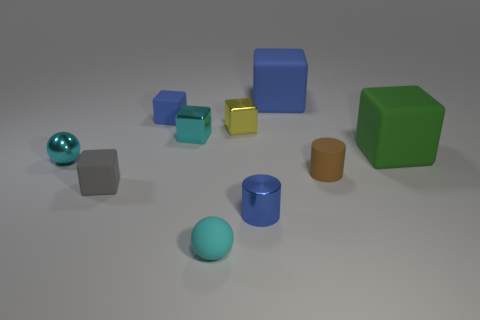Is the number of blue shiny cylinders that are to the left of the tiny gray block less than the number of large cyan matte things?
Your response must be concise. No. What shape is the blue thing that is made of the same material as the yellow cube?
Provide a succinct answer. Cylinder. There is a tiny blue thing that is left of the tiny cyan matte sphere; does it have the same shape as the small blue thing that is in front of the green matte object?
Ensure brevity in your answer.  No. Are there fewer cyan cubes that are behind the small blue rubber block than cubes on the left side of the shiny cylinder?
Keep it short and to the point. Yes. There is a metal object that is the same color as the small metallic ball; what shape is it?
Provide a short and direct response. Cube. How many brown matte cylinders are the same size as the yellow metallic block?
Provide a succinct answer. 1. Do the cube that is in front of the green block and the small cyan block have the same material?
Ensure brevity in your answer.  No. Are any big yellow blocks visible?
Your answer should be compact. No. There is a green cube that is made of the same material as the gray cube; what is its size?
Offer a very short reply. Large. Are there any tiny matte objects of the same color as the tiny metal sphere?
Your answer should be compact. Yes. 